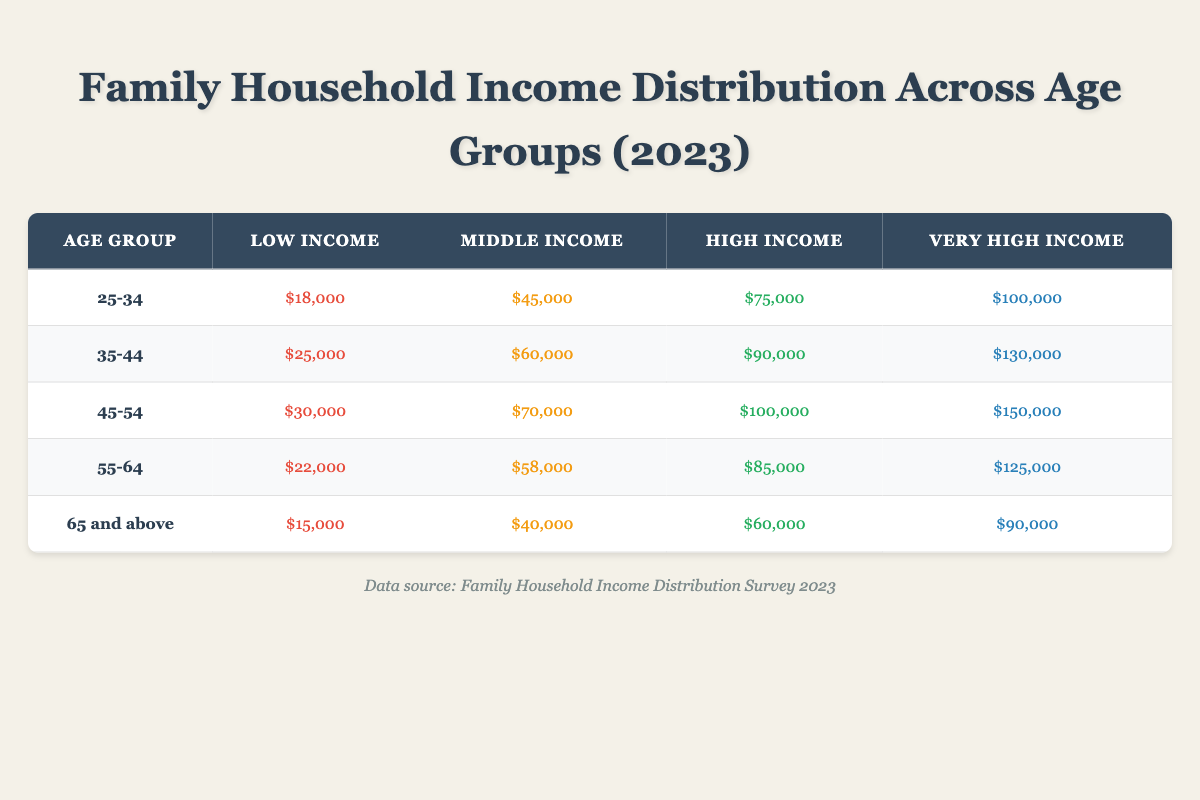What is the low income value for the 45-54 age group? The low income value for the 45-54 age group can be found in the corresponding row of the table. It shows a value of $30,000.
Answer: $30,000 Which age group has the highest very high income? Looking at the "Very High Income" column, the age group with the highest value is 45-54, which has a value of $150,000.
Answer: 45-54 What is the difference between the low income of the 25-34 age group and the 65 and above age group? The low income for the 25-34 age group is $18,000, while for the 65 and above age group, it is $15,000. The difference is $18,000 - $15,000 = $3,000.
Answer: $3,000 Is it true that the middle income for the 35-44 age group exceeds the high income for the 55-64 age group? The middle income for the 35-44 age group is $60,000 and the high income for the 55-64 age group is $85,000. Since $60,000 does not exceed $85,000, the statement is false.
Answer: False What is the average income for the low-income category across all age groups? To calculate the average, sum the low income values for all age groups: $18,000 + $25,000 + $30,000 + $22,000 + $15,000 = $110,000. There are 5 age groups, so the average is $110,000 / 5 = $22,000.
Answer: $22,000 Which age group has the lowest middle income, and what is its value? By reviewing the middle income values, the 65 and above age group has the lowest middle income at $40,000.
Answer: 65 and above, $40,000 What is the total very high income across all age groups? To find the total very high income, sum the values from the "Very High Income" column: $100,000 + $130,000 + $150,000 + $125,000 + $90,000 = $695,000.
Answer: $695,000 